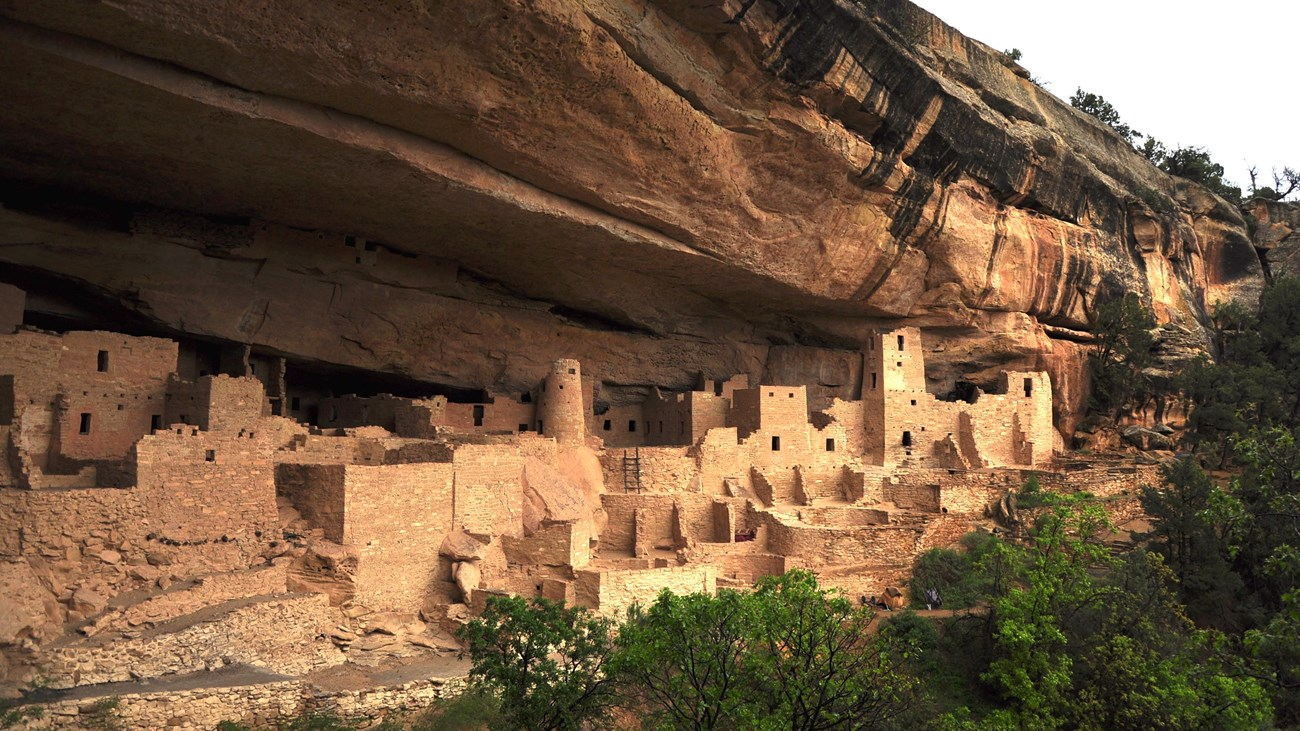What do you think the legacy of the ancient Puebloan people is to modern society? The legacy of the ancient Puebloan people to modern society is immense and multi-faceted. Their innovative architectural techniques and sustainable living practices continue to inspire and inform contemporary approaches to building and environmental stewardship. They demonstrated the importance of community, cooperation, and adaptability in overcoming harsh living conditions, offering timeless lessons in resilience and resourcefulness. Their cultural and spiritual traditions contribute to the rich tapestry of human history, underscoring the significance of preserving heritage and understanding our collective past. The cliff dwellings themselves remain a powerful symbol of human ingenuity and the enduring connection between people and the environment. 